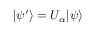<formula> <loc_0><loc_0><loc_500><loc_500>| \psi ^ { \prime } \rangle = U _ { \alpha } | \psi \rangle</formula> 